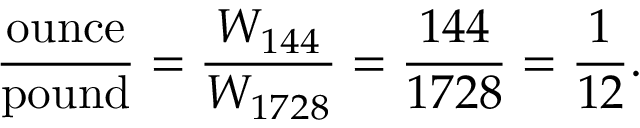Convert formula to latex. <formula><loc_0><loc_0><loc_500><loc_500>{ \frac { o u n c e } { p o u n d } } = { \frac { W _ { 1 4 4 } } { W _ { 1 7 2 8 } } } = { \frac { 1 4 4 } { 1 7 2 8 } } = { \frac { 1 } { 1 2 } } .</formula> 